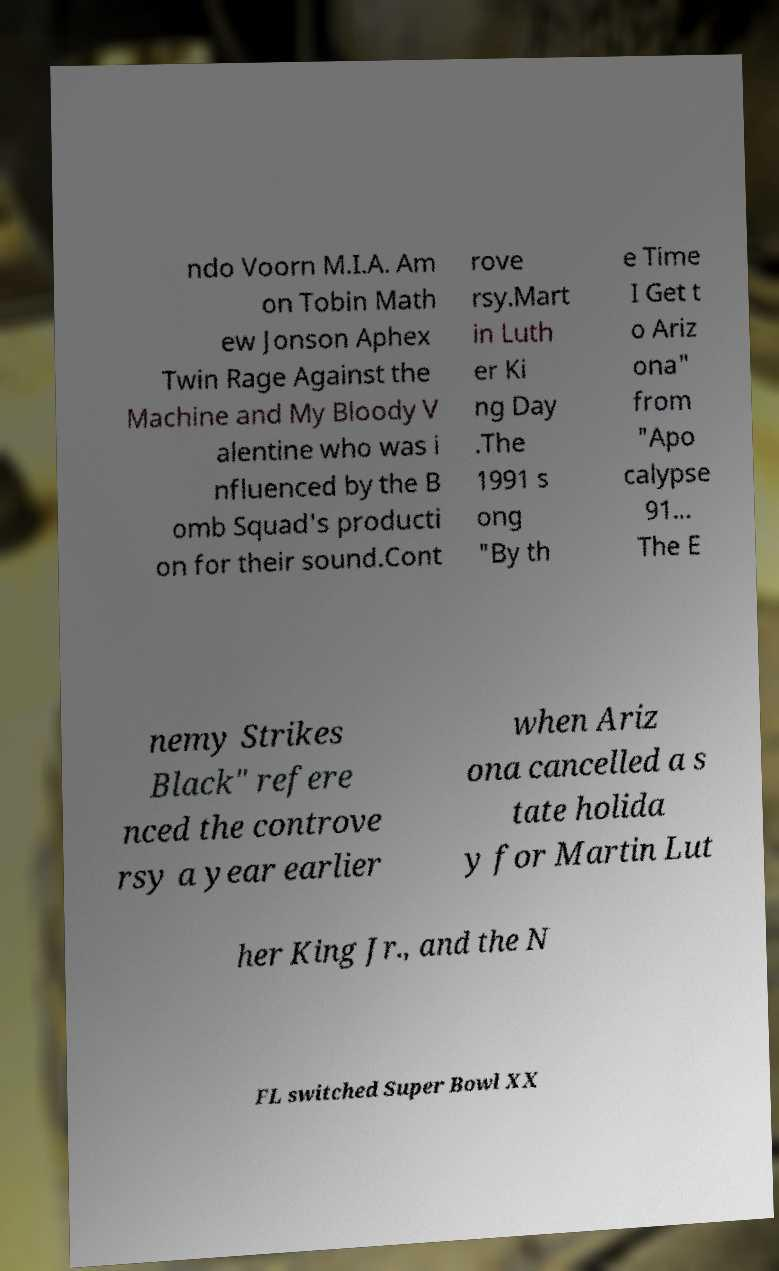I need the written content from this picture converted into text. Can you do that? ndo Voorn M.I.A. Am on Tobin Math ew Jonson Aphex Twin Rage Against the Machine and My Bloody V alentine who was i nfluenced by the B omb Squad's producti on for their sound.Cont rove rsy.Mart in Luth er Ki ng Day .The 1991 s ong "By th e Time I Get t o Ariz ona" from "Apo calypse 91... The E nemy Strikes Black" refere nced the controve rsy a year earlier when Ariz ona cancelled a s tate holida y for Martin Lut her King Jr., and the N FL switched Super Bowl XX 